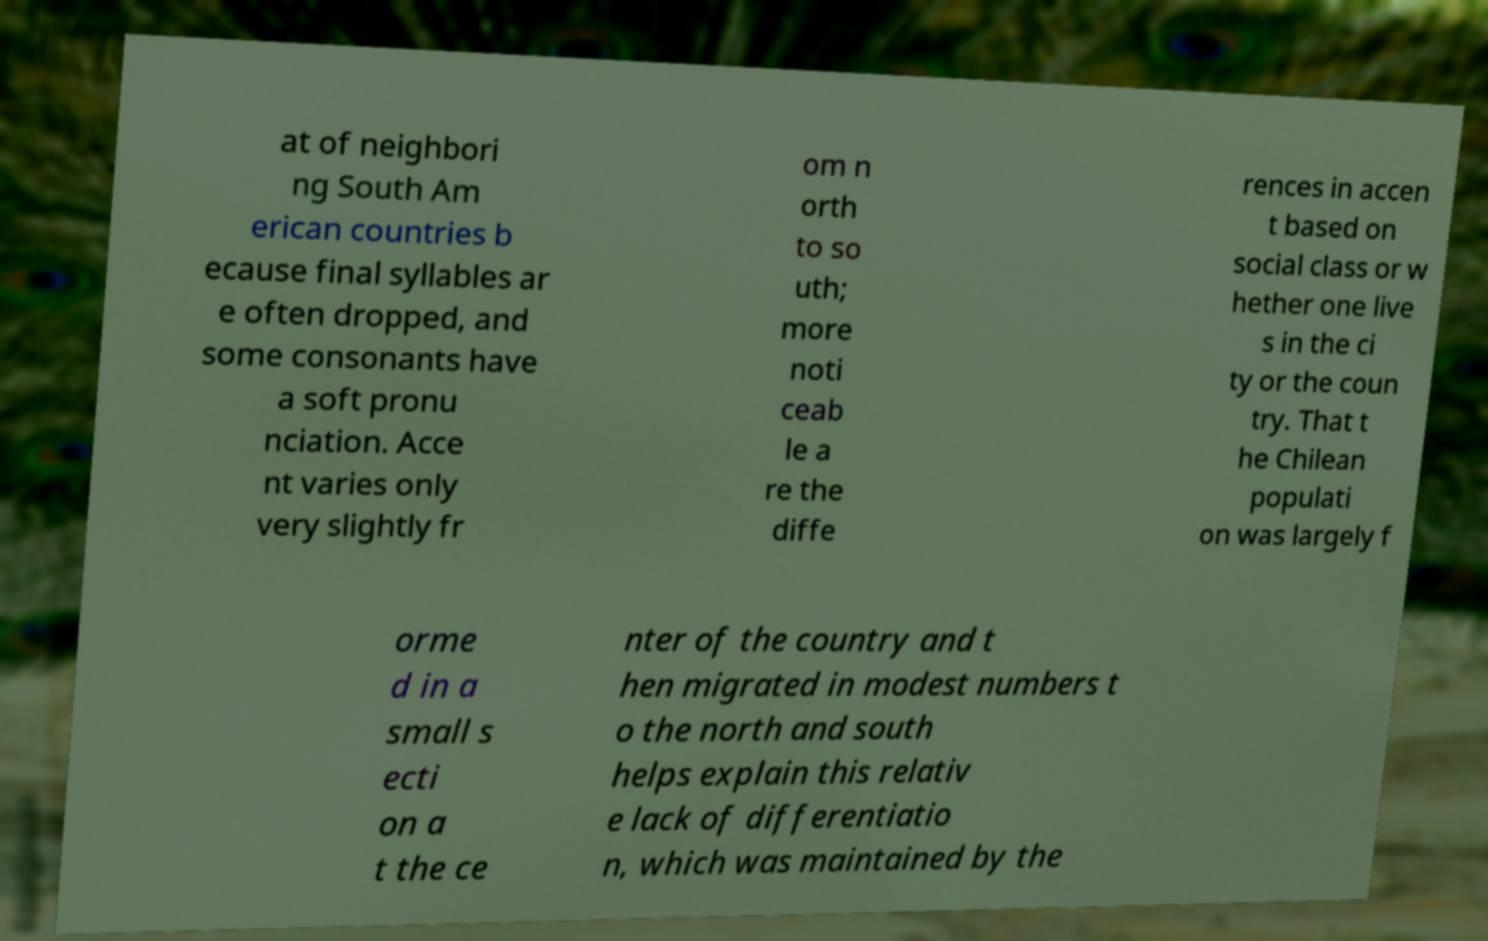Could you extract and type out the text from this image? at of neighbori ng South Am erican countries b ecause final syllables ar e often dropped, and some consonants have a soft pronu nciation. Acce nt varies only very slightly fr om n orth to so uth; more noti ceab le a re the diffe rences in accen t based on social class or w hether one live s in the ci ty or the coun try. That t he Chilean populati on was largely f orme d in a small s ecti on a t the ce nter of the country and t hen migrated in modest numbers t o the north and south helps explain this relativ e lack of differentiatio n, which was maintained by the 